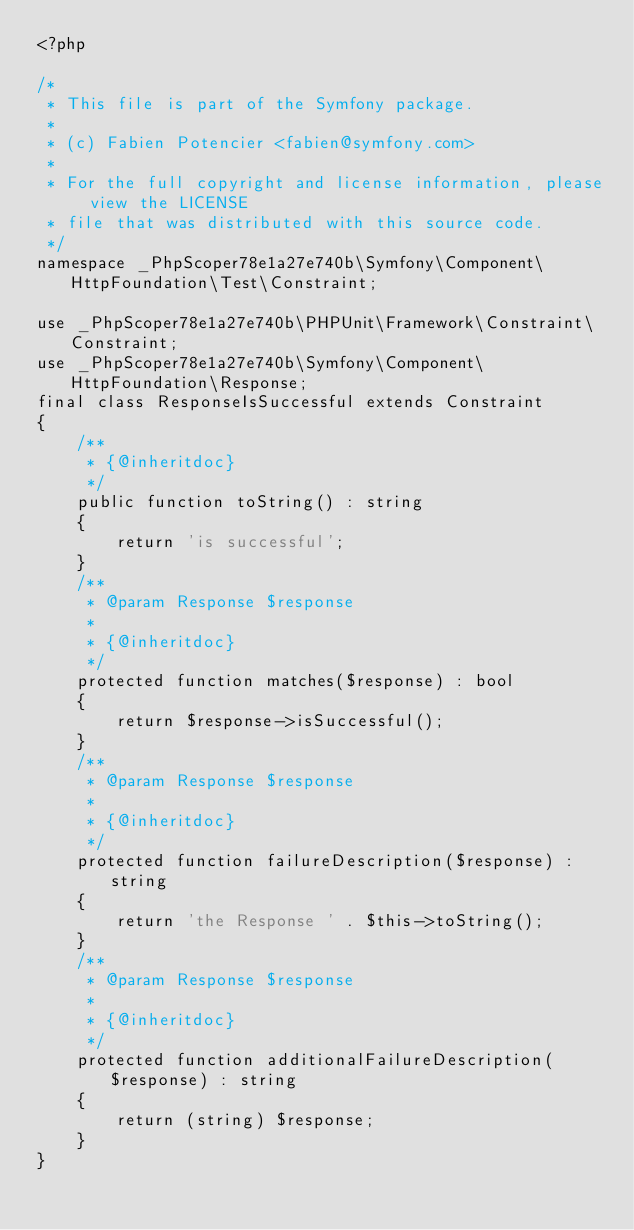<code> <loc_0><loc_0><loc_500><loc_500><_PHP_><?php

/*
 * This file is part of the Symfony package.
 *
 * (c) Fabien Potencier <fabien@symfony.com>
 *
 * For the full copyright and license information, please view the LICENSE
 * file that was distributed with this source code.
 */
namespace _PhpScoper78e1a27e740b\Symfony\Component\HttpFoundation\Test\Constraint;

use _PhpScoper78e1a27e740b\PHPUnit\Framework\Constraint\Constraint;
use _PhpScoper78e1a27e740b\Symfony\Component\HttpFoundation\Response;
final class ResponseIsSuccessful extends Constraint
{
    /**
     * {@inheritdoc}
     */
    public function toString() : string
    {
        return 'is successful';
    }
    /**
     * @param Response $response
     *
     * {@inheritdoc}
     */
    protected function matches($response) : bool
    {
        return $response->isSuccessful();
    }
    /**
     * @param Response $response
     *
     * {@inheritdoc}
     */
    protected function failureDescription($response) : string
    {
        return 'the Response ' . $this->toString();
    }
    /**
     * @param Response $response
     *
     * {@inheritdoc}
     */
    protected function additionalFailureDescription($response) : string
    {
        return (string) $response;
    }
}
</code> 